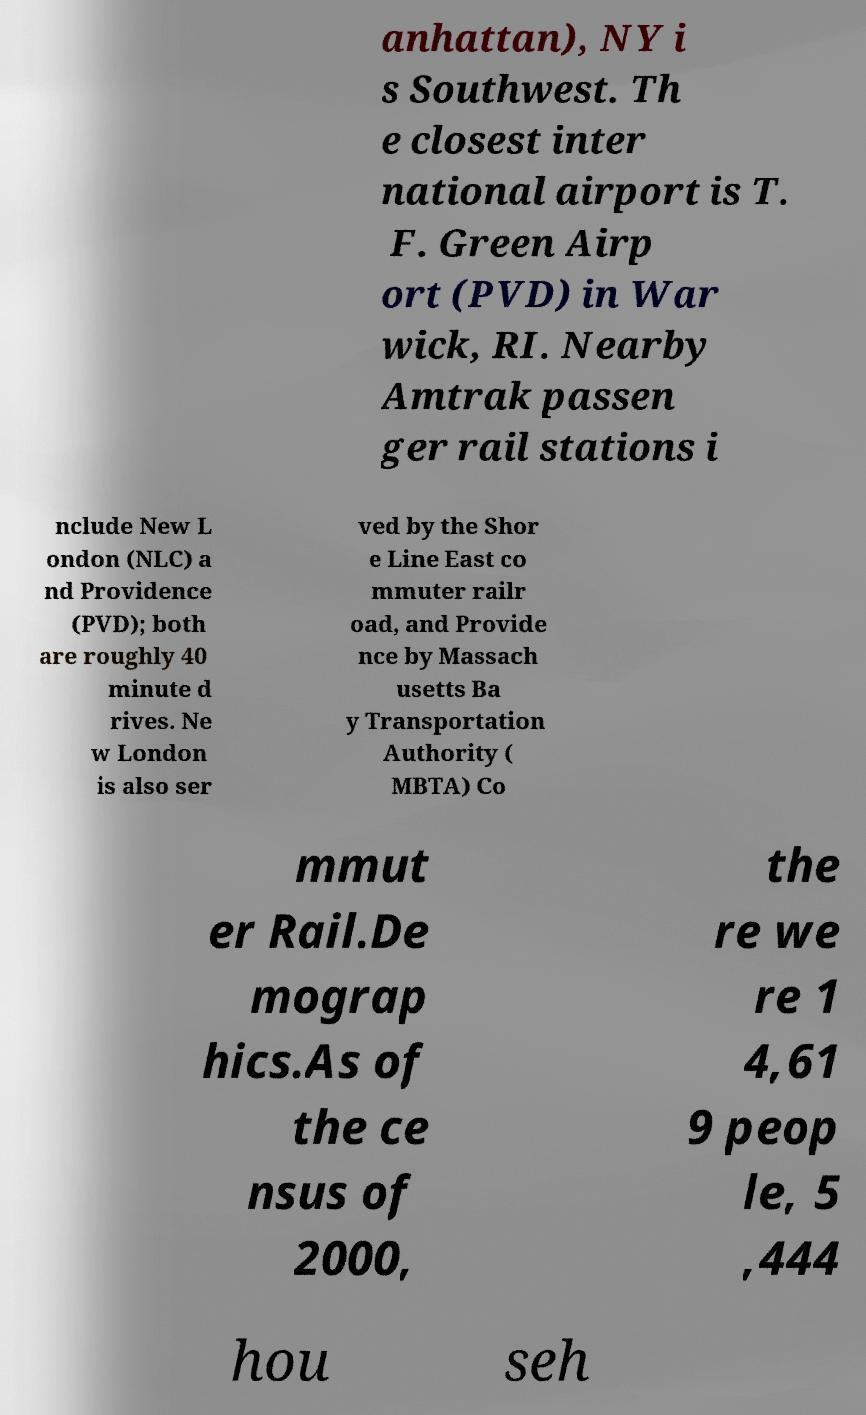I need the written content from this picture converted into text. Can you do that? anhattan), NY i s Southwest. Th e closest inter national airport is T. F. Green Airp ort (PVD) in War wick, RI. Nearby Amtrak passen ger rail stations i nclude New L ondon (NLC) a nd Providence (PVD); both are roughly 40 minute d rives. Ne w London is also ser ved by the Shor e Line East co mmuter railr oad, and Provide nce by Massach usetts Ba y Transportation Authority ( MBTA) Co mmut er Rail.De mograp hics.As of the ce nsus of 2000, the re we re 1 4,61 9 peop le, 5 ,444 hou seh 